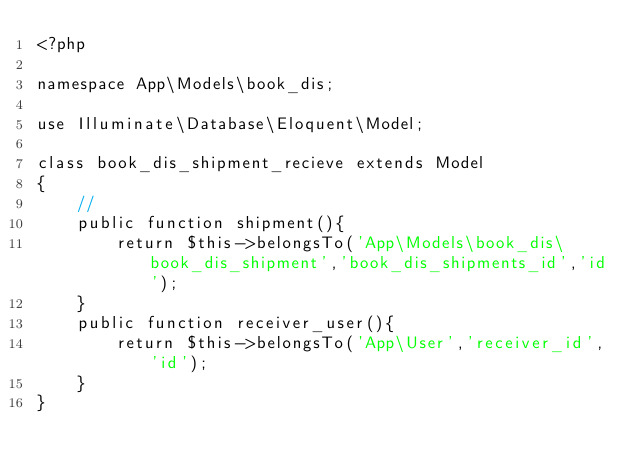Convert code to text. <code><loc_0><loc_0><loc_500><loc_500><_PHP_><?php

namespace App\Models\book_dis;

use Illuminate\Database\Eloquent\Model;

class book_dis_shipment_recieve extends Model
{
    //
    public function shipment(){
        return $this->belongsTo('App\Models\book_dis\book_dis_shipment','book_dis_shipments_id','id');
    }
    public function receiver_user(){
        return $this->belongsTo('App\User','receiver_id','id');
    }
}</code> 